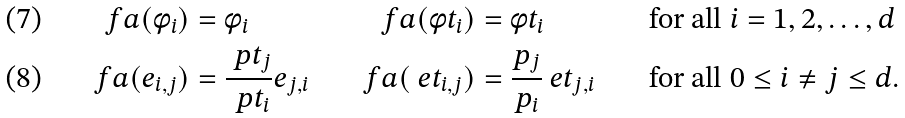<formula> <loc_0><loc_0><loc_500><loc_500>\ f a ( \phi _ { i } ) & = \phi _ { i } & \ f a ( \phi t _ { i } ) & = \phi t _ { i } & & \text { for all } i = 1 , 2 , \dots , d \\ \ f a ( e _ { i , j } ) & = \frac { \ p t _ { j } } { \ p t _ { i } } e _ { j , i } & \ f a ( \ e t _ { i , j } ) & = \frac { p _ { j } } { p _ { i } } \ e t _ { j , i } & & \text { for all } 0 \leq i \neq j \leq d .</formula> 